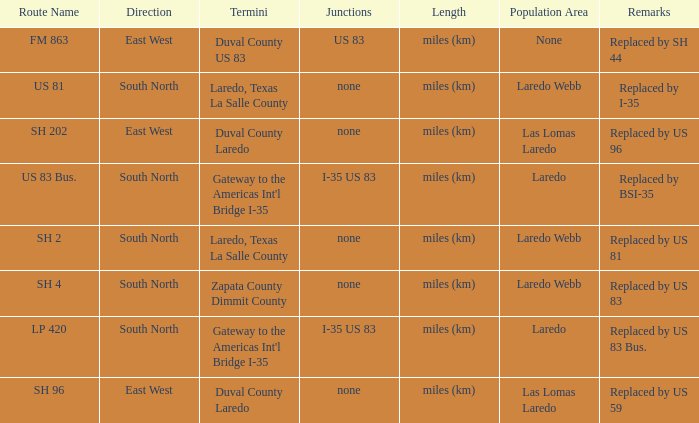Which routes have  "replaced by US 81" listed in their remarks section? SH 2. 